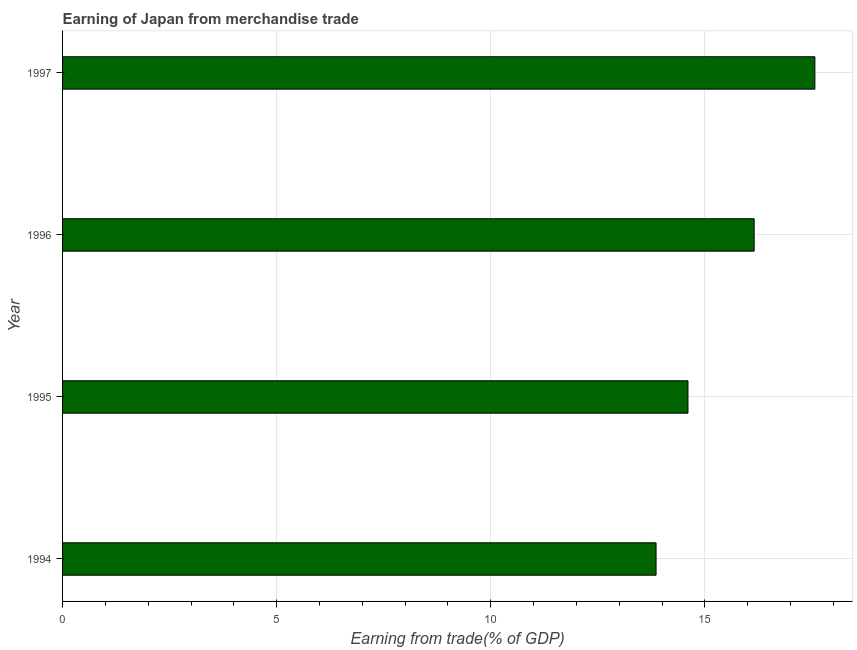Does the graph contain any zero values?
Keep it short and to the point. No. What is the title of the graph?
Offer a terse response. Earning of Japan from merchandise trade. What is the label or title of the X-axis?
Ensure brevity in your answer.  Earning from trade(% of GDP). What is the earning from merchandise trade in 1994?
Keep it short and to the point. 13.86. Across all years, what is the maximum earning from merchandise trade?
Offer a very short reply. 17.57. Across all years, what is the minimum earning from merchandise trade?
Keep it short and to the point. 13.86. In which year was the earning from merchandise trade maximum?
Your response must be concise. 1997. What is the sum of the earning from merchandise trade?
Make the answer very short. 62.18. What is the difference between the earning from merchandise trade in 1994 and 1996?
Your response must be concise. -2.29. What is the average earning from merchandise trade per year?
Make the answer very short. 15.55. What is the median earning from merchandise trade?
Give a very brief answer. 15.38. Do a majority of the years between 1997 and 1996 (inclusive) have earning from merchandise trade greater than 1 %?
Your response must be concise. No. What is the ratio of the earning from merchandise trade in 1994 to that in 1997?
Offer a terse response. 0.79. Is the earning from merchandise trade in 1994 less than that in 1995?
Make the answer very short. Yes. What is the difference between the highest and the second highest earning from merchandise trade?
Give a very brief answer. 1.42. What is the difference between the highest and the lowest earning from merchandise trade?
Your response must be concise. 3.71. How many bars are there?
Make the answer very short. 4. How many years are there in the graph?
Ensure brevity in your answer.  4. What is the difference between two consecutive major ticks on the X-axis?
Make the answer very short. 5. What is the Earning from trade(% of GDP) of 1994?
Provide a succinct answer. 13.86. What is the Earning from trade(% of GDP) of 1995?
Provide a succinct answer. 14.6. What is the Earning from trade(% of GDP) of 1996?
Give a very brief answer. 16.15. What is the Earning from trade(% of GDP) in 1997?
Give a very brief answer. 17.57. What is the difference between the Earning from trade(% of GDP) in 1994 and 1995?
Provide a short and direct response. -0.74. What is the difference between the Earning from trade(% of GDP) in 1994 and 1996?
Your response must be concise. -2.29. What is the difference between the Earning from trade(% of GDP) in 1994 and 1997?
Provide a succinct answer. -3.71. What is the difference between the Earning from trade(% of GDP) in 1995 and 1996?
Make the answer very short. -1.55. What is the difference between the Earning from trade(% of GDP) in 1995 and 1997?
Your answer should be compact. -2.96. What is the difference between the Earning from trade(% of GDP) in 1996 and 1997?
Provide a succinct answer. -1.42. What is the ratio of the Earning from trade(% of GDP) in 1994 to that in 1995?
Provide a succinct answer. 0.95. What is the ratio of the Earning from trade(% of GDP) in 1994 to that in 1996?
Offer a terse response. 0.86. What is the ratio of the Earning from trade(% of GDP) in 1994 to that in 1997?
Give a very brief answer. 0.79. What is the ratio of the Earning from trade(% of GDP) in 1995 to that in 1996?
Provide a short and direct response. 0.9. What is the ratio of the Earning from trade(% of GDP) in 1995 to that in 1997?
Offer a terse response. 0.83. What is the ratio of the Earning from trade(% of GDP) in 1996 to that in 1997?
Offer a very short reply. 0.92. 